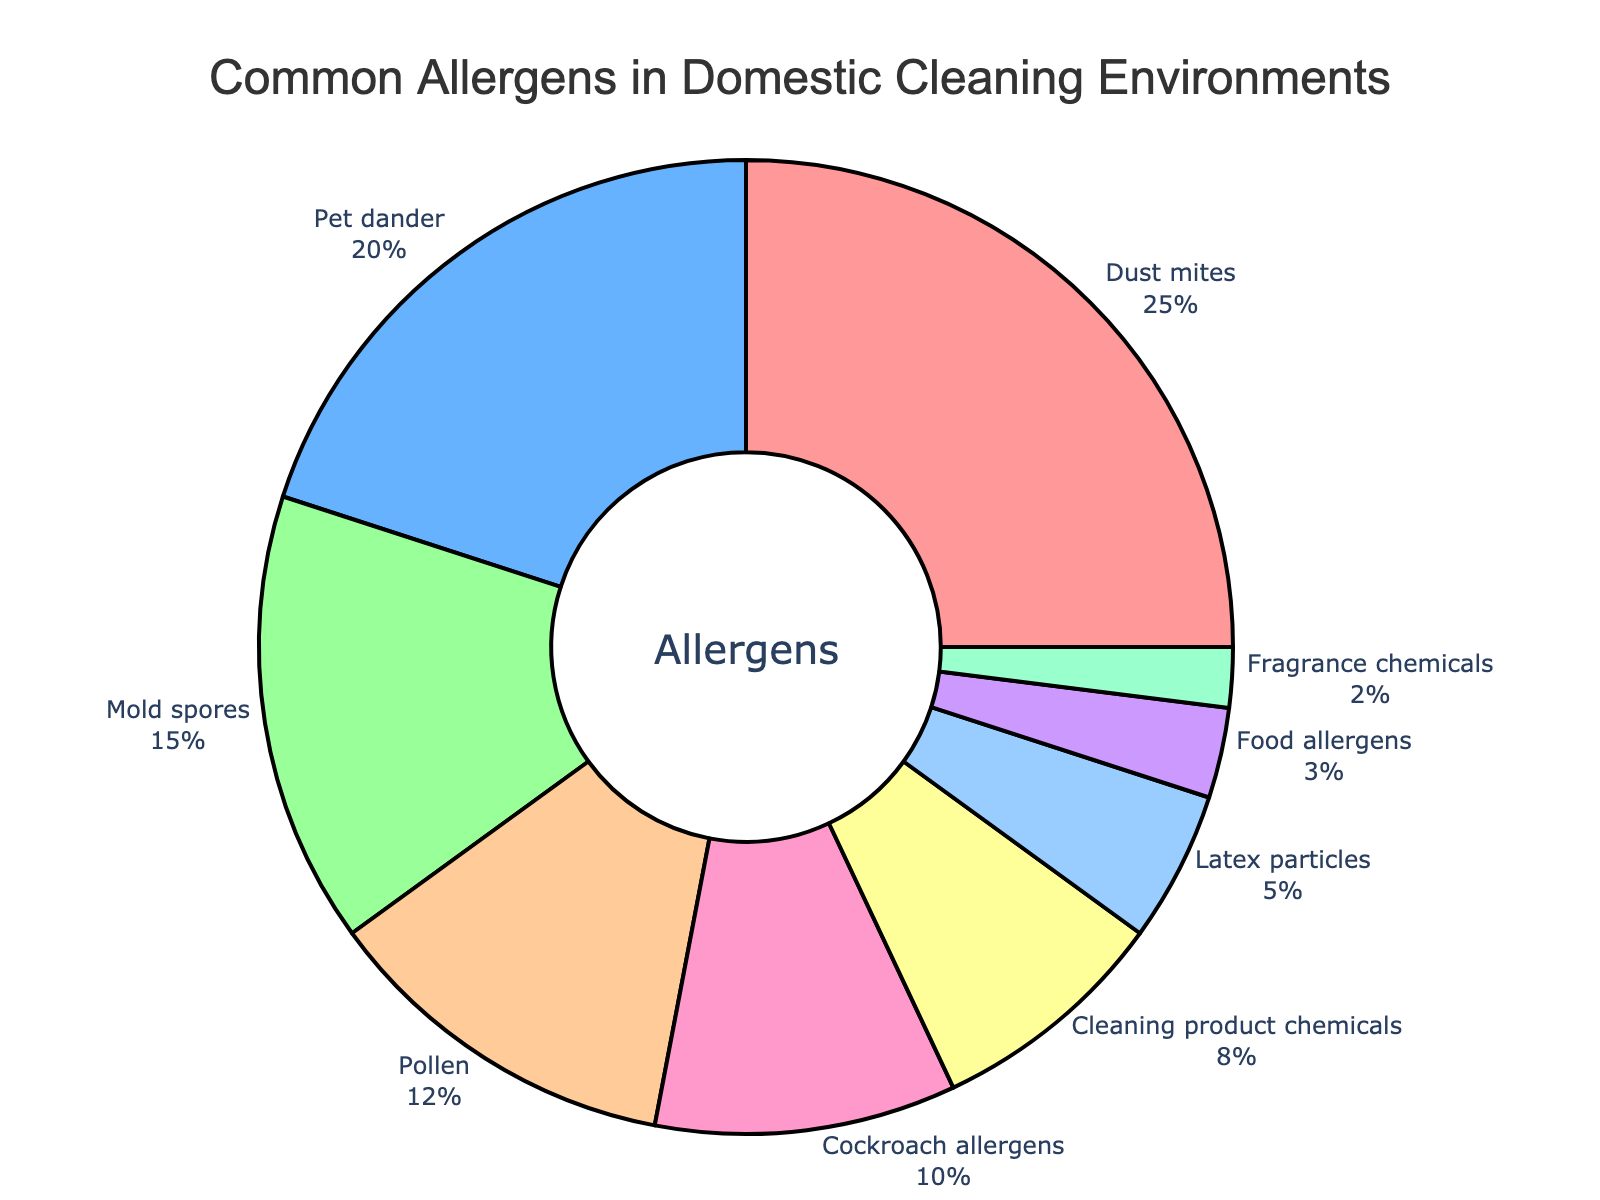What percentage of allergens do dust mites and mold spores contribute together? To find the combined percentage of dust mites and mold spores, add their individual percentages: 25% (dust mites) + 15% (mold spores) = 40%.
Answer: 40% Which allergen has a higher percentage: pet dander or cleaning product chemicals? Comparing the percentages, pet dander has 20% while cleaning product chemicals have 8%. Since 20% is greater than 8%, pet dander has a higher percentage.
Answer: Pet dander What is the smallest percentage of allergens, and which allergen does it represent? The smallest percentage is 2%, and it represents fragrance chemicals.
Answer: Fragrance chemicals How do the percentages of cockroach allergens and food allergens compare? Cockroach allergens contribute 10% while food allergens contribute 3%. Since 10% is greater than 3%, cockroach allergens have a higher percentage.
Answer: Cockroach allergens If the percentages of pet dander and mold spores were combined, would they be greater than the percentage of dust mites? Add the percentages of pet dander (20%) and mold spores (15%): 20% + 15% = 35%. Dust mites have a percentage of 25%. Since 35% is greater than 25%, the combined percentage is greater.
Answer: Yes Which allergen is represented by a red color in the pie chart? The pie chart uses different colors to represent each allergen. From the data provided on the colors, the allergen represented by red is dust mites.
Answer: Dust mites What is the total percentage of allergens attributed to cockroaches and latex particles combined? Add the percentages of cockroach allergens (10%) and latex particles (5%): 10% + 5% = 15%.
Answer: 15% Which three allergens have the highest percentages, and what is their total percentage? The three allergens with the highest percentages are dust mites (25%), pet dander (20%), and mold spores (15%). Add their percentages: 25% + 20% + 15% = 60%.
Answer: 60% Between mold spores and pollen, which one has a lesser percentage, and by how much? Mold spores contribute 15% while pollen contributes 12%. The difference is 15% - 12% = 3%. Therefore, pollen has a lesser percentage by 3%.
Answer: Pollen by 3% What is the difference between the percentage of cleaning product chemicals and latex particles? The percentage of cleaning product chemicals is 8%, and the percentage of latex particles is 5%. The difference is 8% - 5% = 3%.
Answer: 3% 